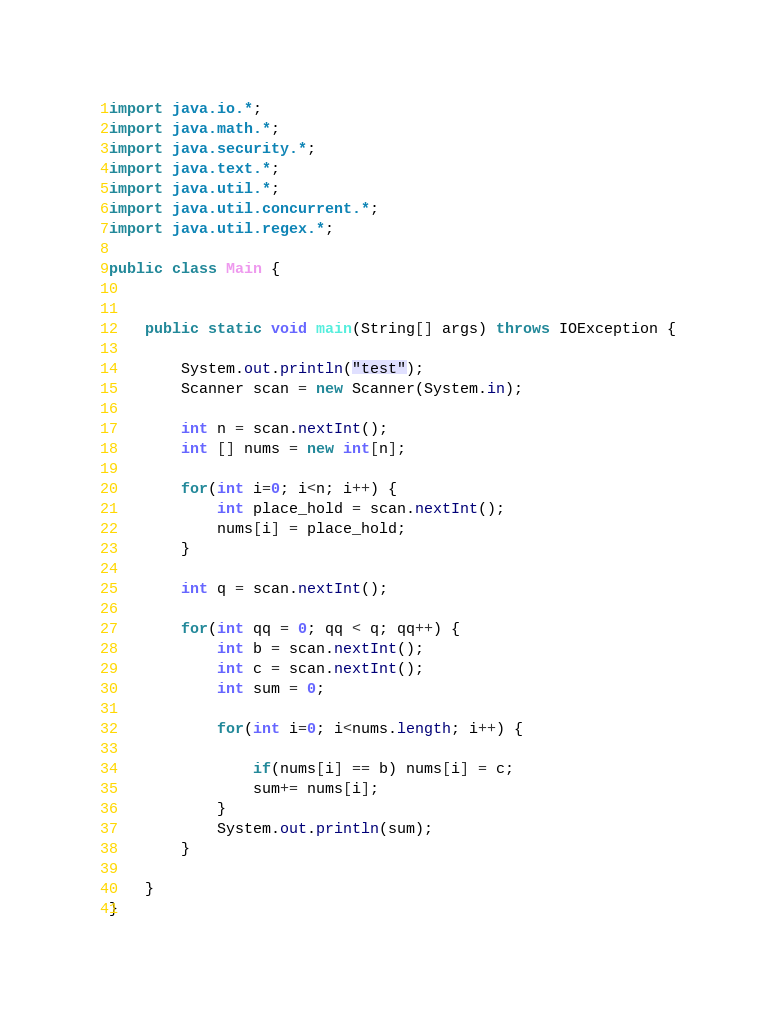<code> <loc_0><loc_0><loc_500><loc_500><_Java_>import java.io.*;
import java.math.*;
import java.security.*;
import java.text.*;
import java.util.*;
import java.util.concurrent.*;
import java.util.regex.*;

public class Main {


    public static void main(String[] args) throws IOException {
    
    	System.out.println("test");
    	Scanner scan = new Scanner(System.in);
    	
    	int n = scan.nextInt();
    	int [] nums = new int[n];
    	
    	for(int i=0; i<n; i++) {
    		int place_hold = scan.nextInt();
    		nums[i] = place_hold;
    	}
    	
    	int q = scan.nextInt();
    	
    	for(int qq = 0; qq < q; qq++) {
    		int b = scan.nextInt();
    		int c = scan.nextInt();
    		int sum = 0;
    		
    		for(int i=0; i<nums.length; i++) {
    			
    			if(nums[i] == b) nums[i] = c;
    			sum+= nums[i];
    		}
    		System.out.println(sum);
    	}
    	
    }
}

</code> 